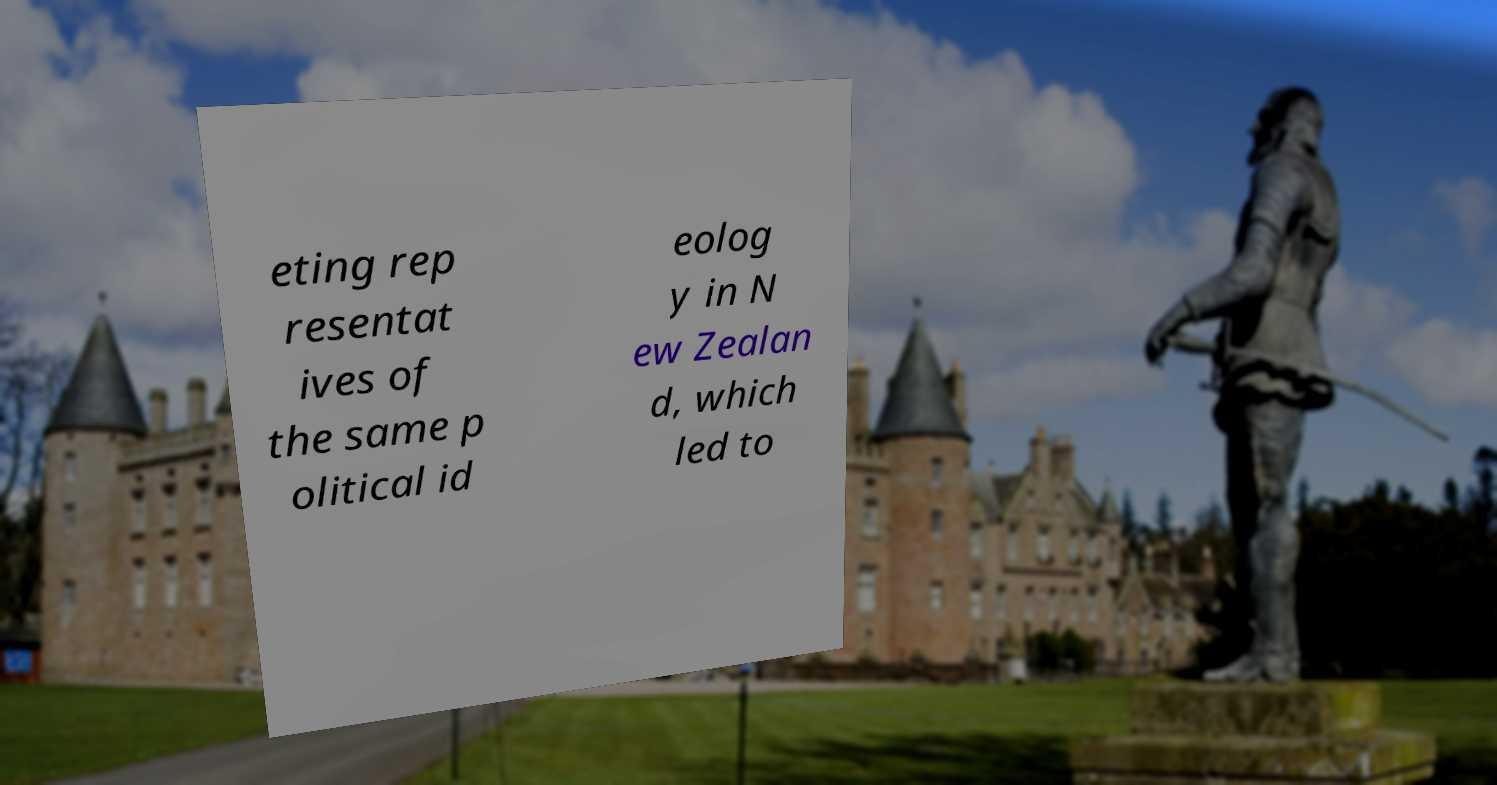Can you read and provide the text displayed in the image?This photo seems to have some interesting text. Can you extract and type it out for me? eting rep resentat ives of the same p olitical id eolog y in N ew Zealan d, which led to 